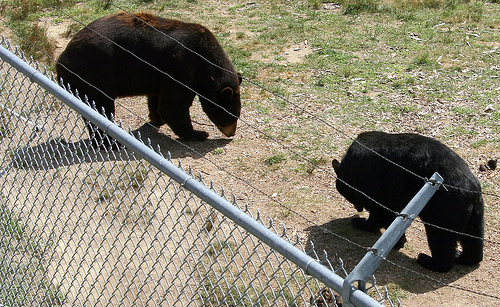How many bears are there? 2 